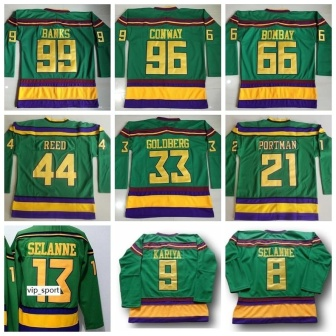Describe the color scheme and design elements of the jerseys. The jerseys exhibit a bold and vivid color scheme featuring green as the primary color, accented by yellow and purple stripes. The color combination creates a striking contrast that is visually appealing. The green background serves as a fitting canvas for the yellow names and numbers, which are prominently displayed on the back of each jersey. The yellow stripes are positioned around the sleeve cuffs and at the bottom of the jerseys, adding a symmetrical design element. The purple stripes sit just above the yellow ones, providing another layer of color contrast that enhances the overall aesthetic. The unique design elements not only make each jersey stand out but also create a cohesive look across the entire collection. Why do you think the designers chose these specific colors and design elements for the jerseys? The choice of green, yellow, and purple for the jerseys could be driven by several factors. Firstly, these colors are often associated with vibrancy and energy, which are fitting for a sports team aiming to portray dynamism and visibility. Green can symbolize growth and vitality, while yellow is frequently linked to optimism and brightness. Purple, traditionally signifying royalty and high value, adds an element of prestige. The stripes and bold lettering serve practical purposes by enhancing visibility and recognition, making it easier for players, referees, and spectators to identify members of the team quickly during fast-paced gameplay. The cohesive design elements ensure that the jerseys are visually appealing both individually and as a group, reinforcing team unity and brand identity. Imagine if each jersey had a story behind it, describing a pivotal moment for the player whose name it bears. What could be the story for 'Banks' with the number 99? Certainly! The jersey belonging to 'Banks' with the number 99 tells the story of an extraordinary player whose remarkable skill and determination led the team to victory in a championship game. 'Banks' was known for his precision and agility on the ice, able to navigate through defenders with ease. The number 99 was earned in a game where he scored the winning goal in the last few seconds, an electrifying moment that was etched in the memories of fans and teammates alike. This goal wasn’t just a point on the scoreboard but a culmination of his hard work, perseverance, and strategic play throughout the season. The jersey symbolizes his legacy, reminding everyone of the strength and excitement he brought to every game. 